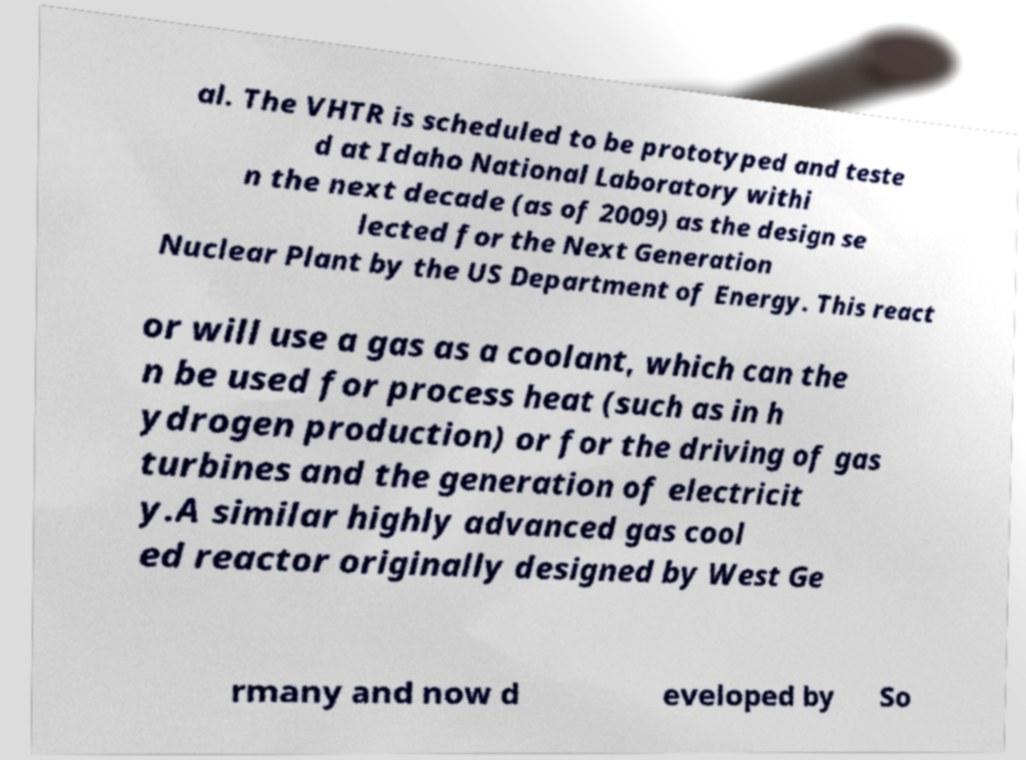What messages or text are displayed in this image? I need them in a readable, typed format. al. The VHTR is scheduled to be prototyped and teste d at Idaho National Laboratory withi n the next decade (as of 2009) as the design se lected for the Next Generation Nuclear Plant by the US Department of Energy. This react or will use a gas as a coolant, which can the n be used for process heat (such as in h ydrogen production) or for the driving of gas turbines and the generation of electricit y.A similar highly advanced gas cool ed reactor originally designed by West Ge rmany and now d eveloped by So 